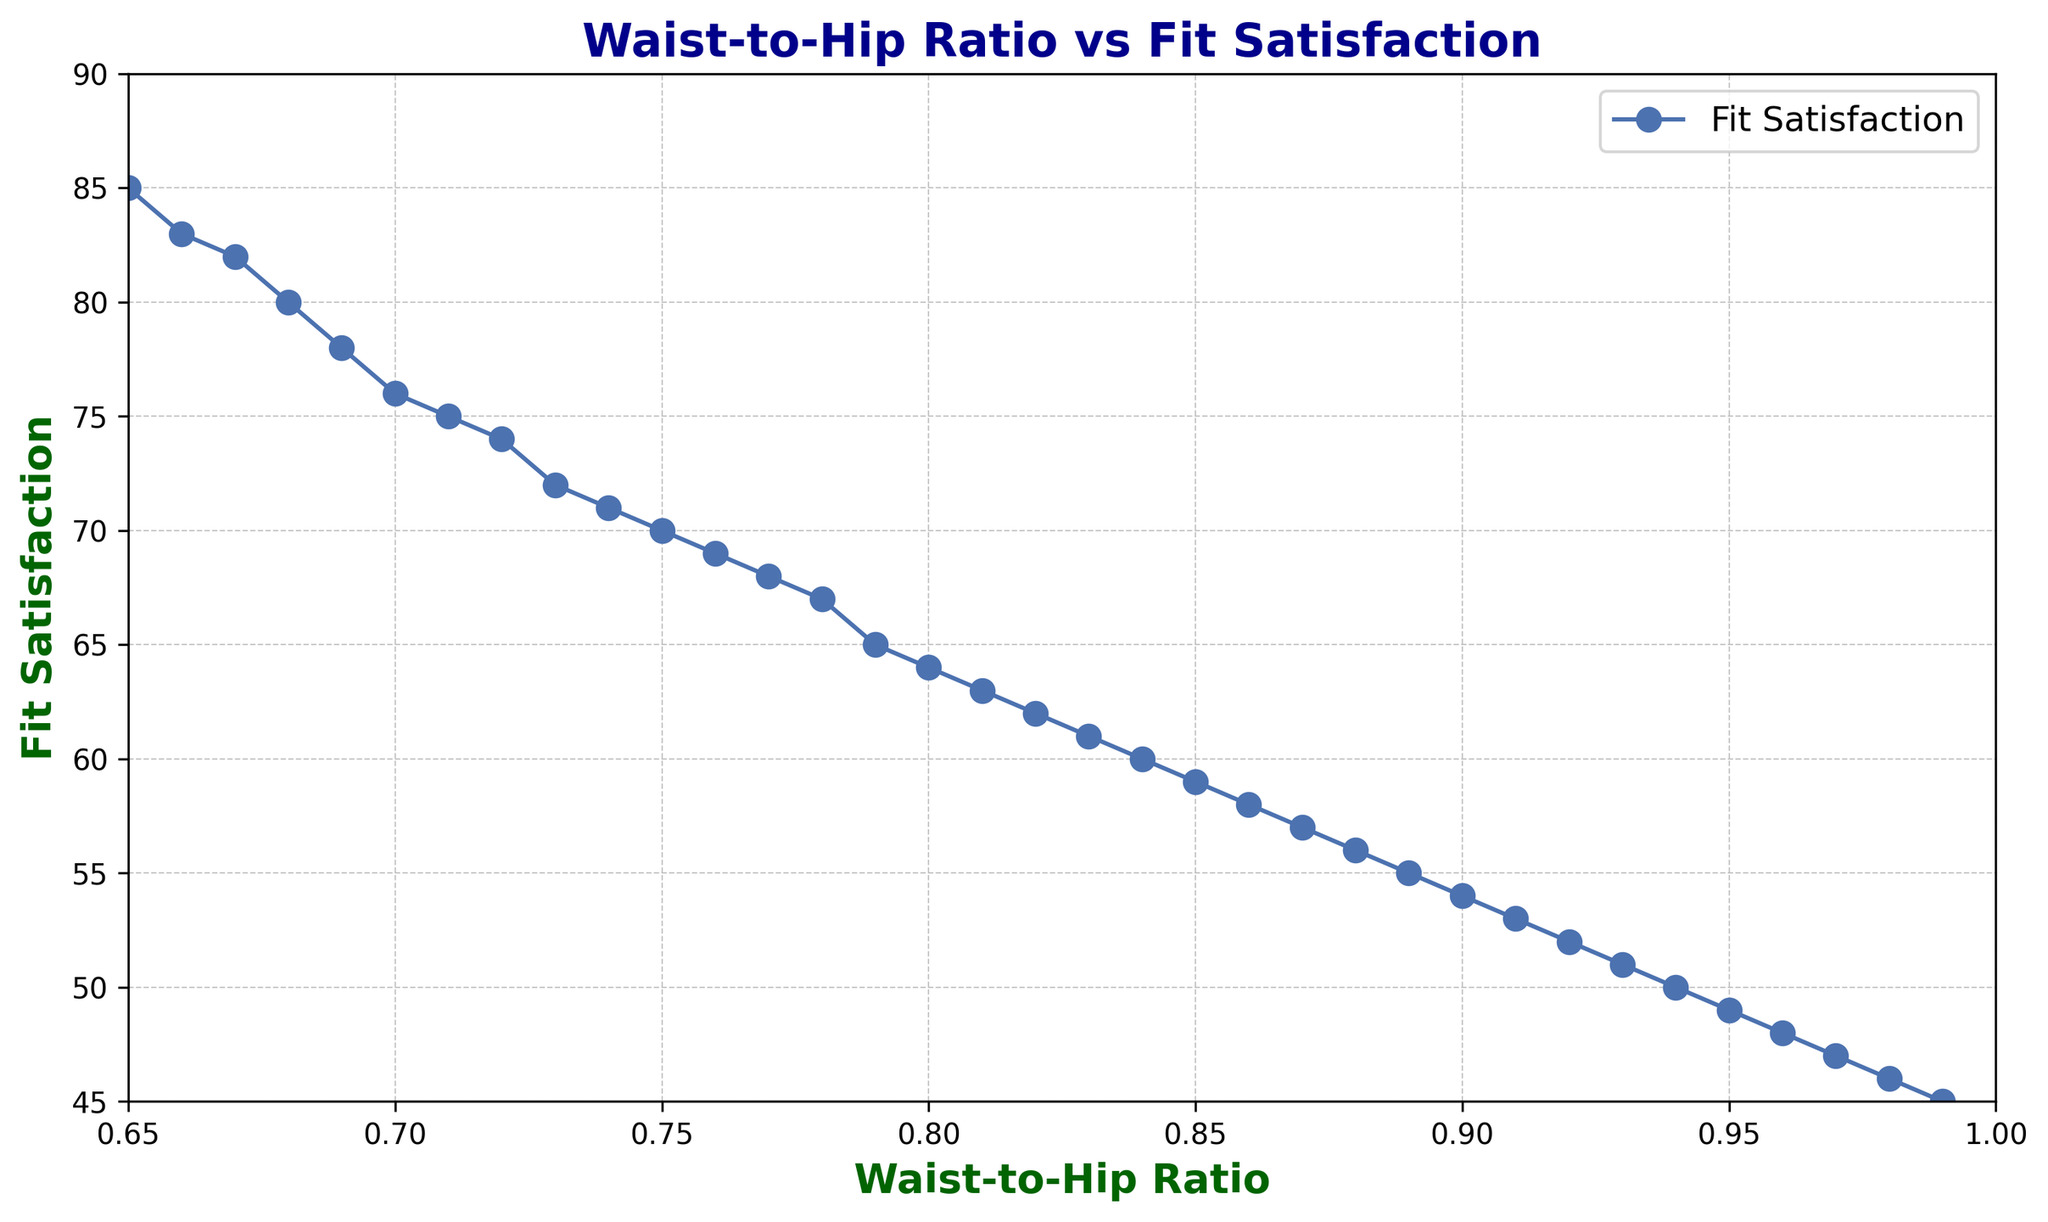What's the relationship between waist-to-hip ratio and fit satisfaction? By looking at the trend line in the plot, we can see that as the waist-to-hip ratio increases, the fit satisfaction decreases. This indicates a negative correlation.
Answer: Negative correlation What is the fit satisfaction for a waist-to-hip ratio of 0.75? From the plot, we can see that the fit satisfaction for a waist-to-hip ratio of 0.75 is 70.
Answer: 70 Which waist-to-hip ratio has the highest fit satisfaction and what is its value? The waist-to-hip ratio of 0.65 has the highest fit satisfaction, which is 85.
Answer: 0.65 and 85 By how much does fit satisfaction decrease when the waist-to-hip ratio increases from 0.80 to 0.85? The fit satisfaction decreases from 64 at a waist-to-hip ratio of 0.80 to 59 at 0.85. The decrease is 64 - 59 = 5.
Answer: 5 What is the overall trend shown in the plot? The plot shows a decreasing trend in fit satisfaction as the waist-to-hip ratio increases.
Answer: Decreasing trend Is there a waist-to-hip ratio for which fit satisfaction reaches exactly 50? Yes, the fit satisfaction is 50 for a waist-to-hip ratio of 0.94.
Answer: Yes For a waist-to-hip ratio of 0.90, what is the fit satisfaction, and is it above or below the median fit satisfaction in the plot? The fit satisfaction for a waist-to-hip ratio of 0.90 is 54. The median of the provided fit satisfaction values (ordered list: 45 to 85) is 65. So, it is below the median.
Answer: 54, below What is the average fit satisfaction for waist-to-hip ratios between 0.80 and 0.90? The waist-to-hip ratios between 0.80 and 0.90 include 0.80, 0.81, 0.82, 0.83, 0.84, 0.85, 0.86, 0.87, 0.88, and 0.89. The corresponding fit satisfaction values are 64, 63, 62, 61, 60, 59, 58, 57, 56, and 55. The average fit satisfaction is (64 + 63 + 62 + 61 + 60 + 59 + 58 + 57 + 56 + 55) / 10 = 59.5.
Answer: 59.5 Is there any waist-to-hip ratio for which fit satisfaction is exactly halfway between the highest and lowest values in the data? The highest fit satisfaction is 85, and the lowest is 45. The halfway point is (85 + 45) / 2 = 65. Looking at the plot, fit satisfaction equals 65 for a waist-to-hip ratio of 0.79.
Answer: Yes, 0.79 